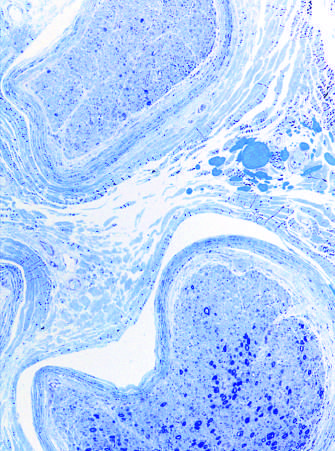s such interfascicular variation in axonal density often seen in neuropathies resulting from vascular injury?
Answer the question using a single word or phrase. Yes 